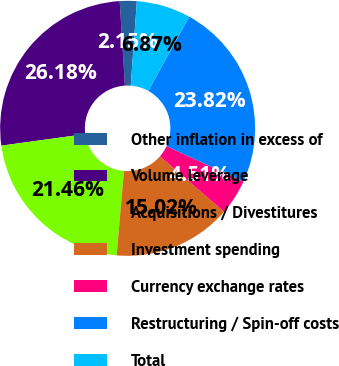Convert chart to OTSL. <chart><loc_0><loc_0><loc_500><loc_500><pie_chart><fcel>Other inflation in excess of<fcel>Volume leverage<fcel>Acquisitions / Divestitures<fcel>Investment spending<fcel>Currency exchange rates<fcel>Restructuring / Spin-off costs<fcel>Total<nl><fcel>2.15%<fcel>26.18%<fcel>21.46%<fcel>15.02%<fcel>4.51%<fcel>23.82%<fcel>6.87%<nl></chart> 